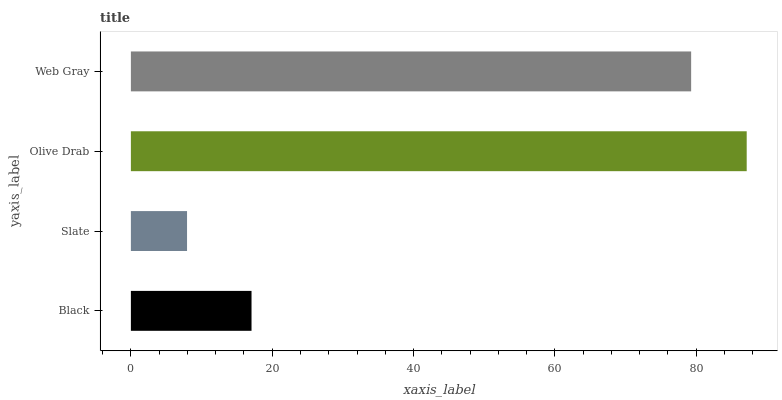Is Slate the minimum?
Answer yes or no. Yes. Is Olive Drab the maximum?
Answer yes or no. Yes. Is Olive Drab the minimum?
Answer yes or no. No. Is Slate the maximum?
Answer yes or no. No. Is Olive Drab greater than Slate?
Answer yes or no. Yes. Is Slate less than Olive Drab?
Answer yes or no. Yes. Is Slate greater than Olive Drab?
Answer yes or no. No. Is Olive Drab less than Slate?
Answer yes or no. No. Is Web Gray the high median?
Answer yes or no. Yes. Is Black the low median?
Answer yes or no. Yes. Is Black the high median?
Answer yes or no. No. Is Web Gray the low median?
Answer yes or no. No. 